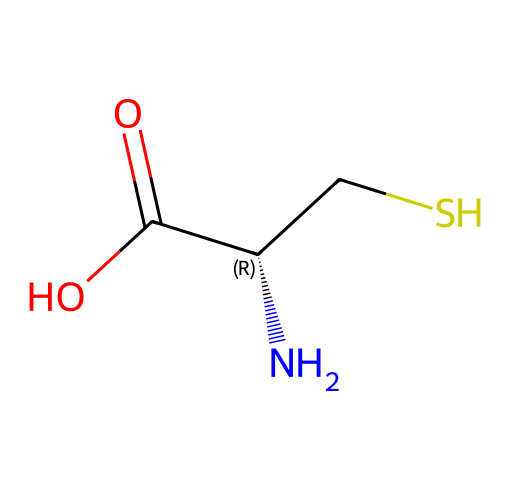What is the primary functional group in cysteine? The structure shows a typical carboxylic acid group (-COOH) at one end and a thiol group (-SH) on another. The presence of the thiol group is notable since cysteine is classified as a thiol amino acid.
Answer: thiol How many carbon atoms are present in this molecule? Counting the carbon atoms in the SMILES representation, there are three carbon atoms: one in the carboxylic acid group, one in the amino group, and one in the side chain.
Answer: three What is the total number of nitrogen atoms in cysteine? The SMILES shows one nitrogen atom as represented by "N" at the start of the structure. This indicates the presence of the amino group.
Answer: one What is the chemical formula for cysteine derived from its structure? By piecing together the counts of carbon, hydrogen, nitrogen, oxygen, and sulfur from the structure, we find it corresponds to the formula C3H7NO2S.
Answer: C3H7NO2S Does cysteine have a chiral center, and if so, where is it located? Yes, cysteine has a chiral center at the alpha carbon (the carbon linked to the amino group, carboxylic acid, and the sulfur group), which enables the existence of two enantiomers.
Answer: alpha carbon What is the impact of the thiol group on the taste profile of cocktails containing cysteine? The thiol group contributes to the overall flavor profile by imparting umami or a savory taste, as well as the potential for complex flavors during fermentation or mixing with other ingredients in cocktails.
Answer: umami 